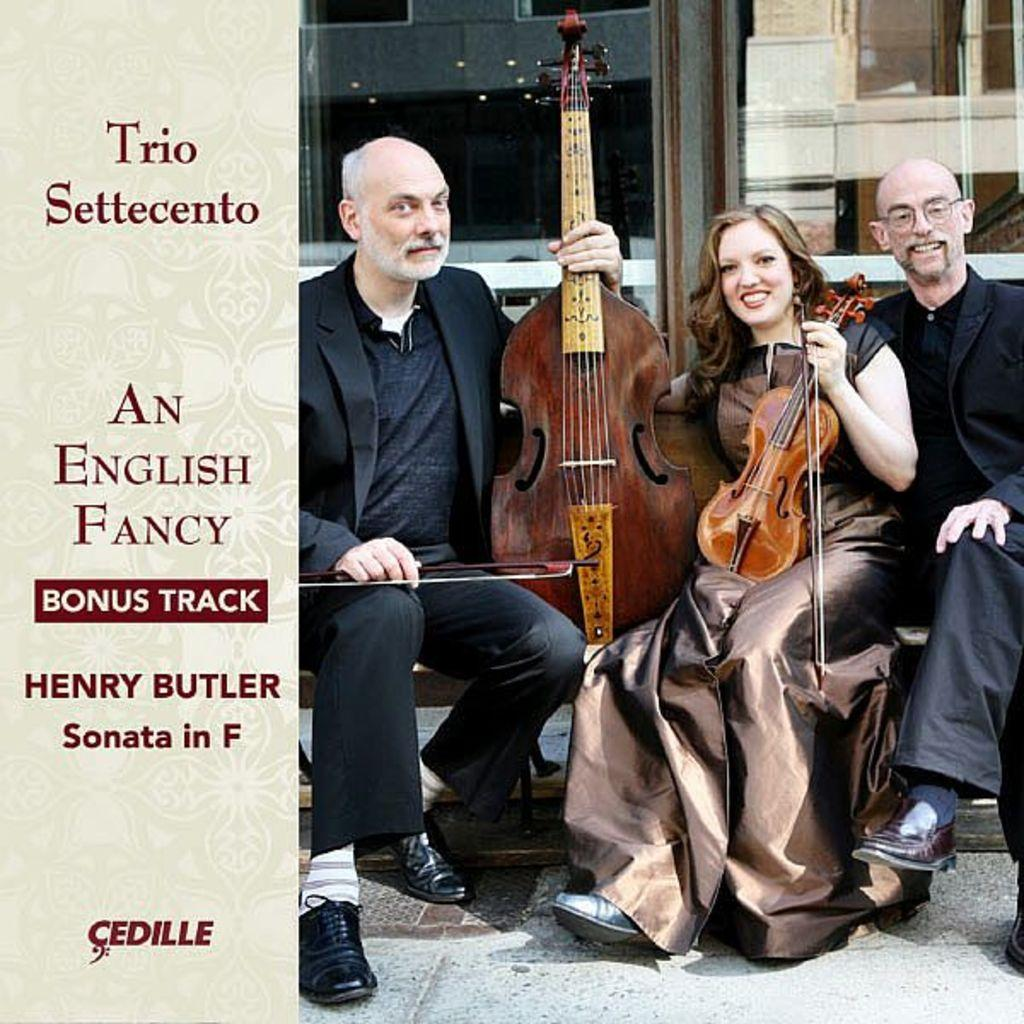What is the main structure in the image? There is a building in the image. How many people are present in the image? There are three people in the image. What are two of the people holding? Two of the people are holding guitars. What type of vest can be seen on the people in the image? There is no vest visible on the people in the image. Is there a cannon present in the image? No, there is no cannon present in the image. 